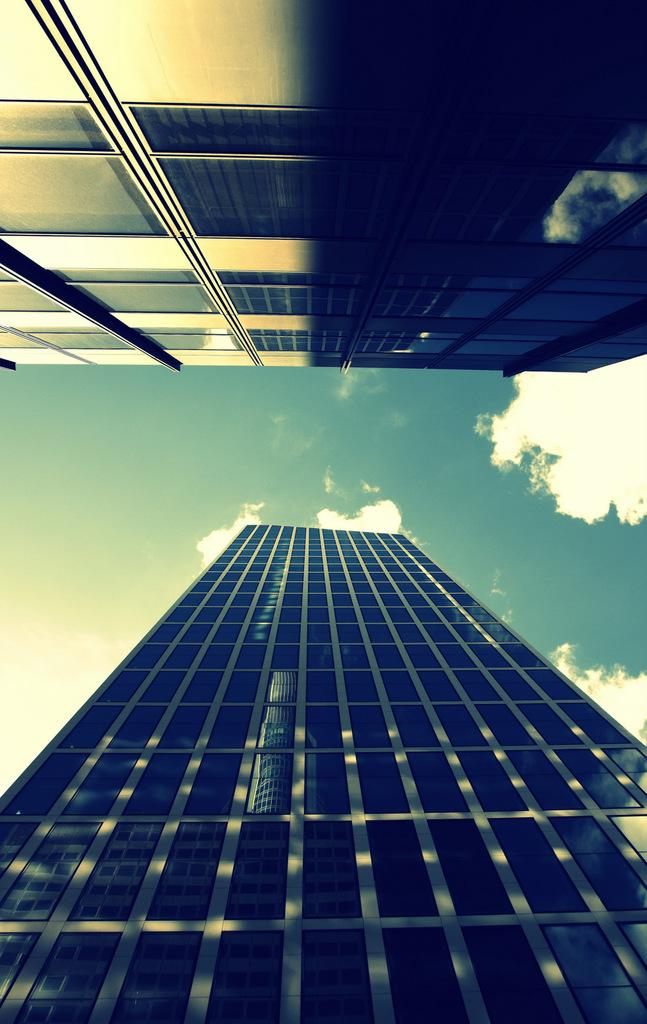What type of structures can be seen in the image? There are buildings in the image. What can be observed in the sky in the image? There are clouds in the image. What else is visible in the image besides the buildings and clouds? The sky is visible in the image. What type of twig can be seen growing from the top of the building in the image? There is no twig growing from the top of any building in the image. 